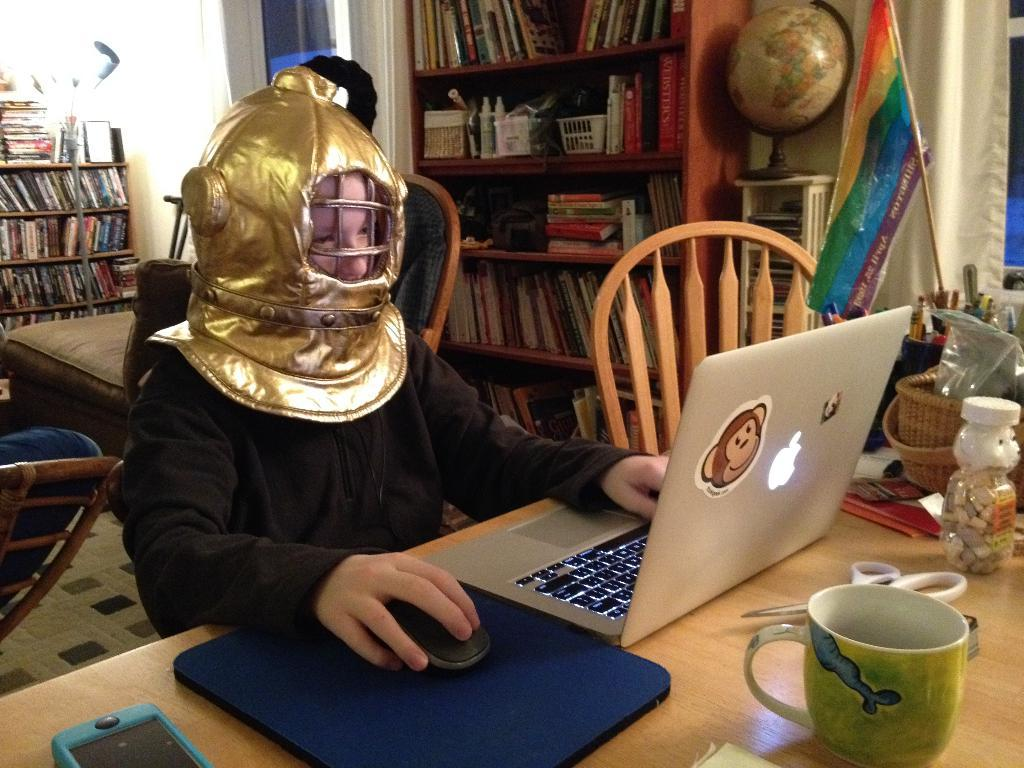Who is the main subject in the image? There is a boy in the image. What is the boy doing in the image? The boy is working on a laptop. What is the boy holding in his hand? The boy is holding a mouse in his hand. What objects can be seen on the table in the image? There is a cup, scissors, and a mobile on the table. What is located on the right side of the image? There is a bookshelf on the right side of the image. What type of patch is the boy applying to the laptop in the image? There is no patch visible on the laptop in the image. 